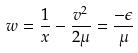<formula> <loc_0><loc_0><loc_500><loc_500>w = \frac { 1 } { x } - \frac { v ^ { 2 } } { 2 \mu } = \frac { - \epsilon } { \mu }</formula> 